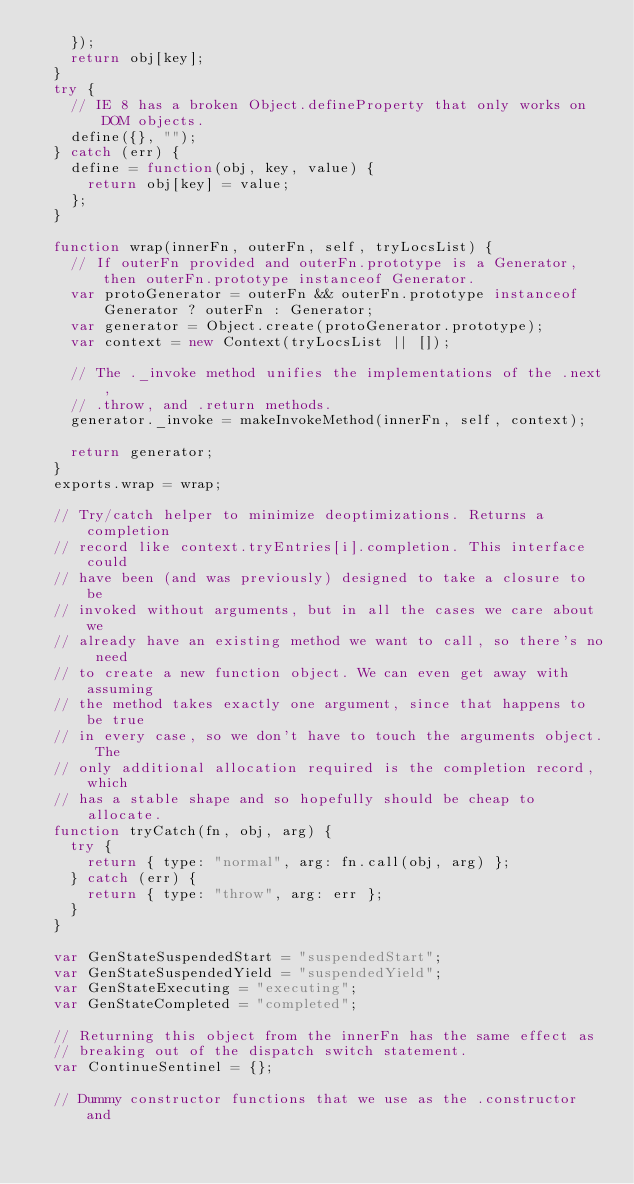<code> <loc_0><loc_0><loc_500><loc_500><_JavaScript_>    });
    return obj[key];
  }
  try {
    // IE 8 has a broken Object.defineProperty that only works on DOM objects.
    define({}, "");
  } catch (err) {
    define = function(obj, key, value) {
      return obj[key] = value;
    };
  }

  function wrap(innerFn, outerFn, self, tryLocsList) {
    // If outerFn provided and outerFn.prototype is a Generator, then outerFn.prototype instanceof Generator.
    var protoGenerator = outerFn && outerFn.prototype instanceof Generator ? outerFn : Generator;
    var generator = Object.create(protoGenerator.prototype);
    var context = new Context(tryLocsList || []);

    // The ._invoke method unifies the implementations of the .next,
    // .throw, and .return methods.
    generator._invoke = makeInvokeMethod(innerFn, self, context);

    return generator;
  }
  exports.wrap = wrap;

  // Try/catch helper to minimize deoptimizations. Returns a completion
  // record like context.tryEntries[i].completion. This interface could
  // have been (and was previously) designed to take a closure to be
  // invoked without arguments, but in all the cases we care about we
  // already have an existing method we want to call, so there's no need
  // to create a new function object. We can even get away with assuming
  // the method takes exactly one argument, since that happens to be true
  // in every case, so we don't have to touch the arguments object. The
  // only additional allocation required is the completion record, which
  // has a stable shape and so hopefully should be cheap to allocate.
  function tryCatch(fn, obj, arg) {
    try {
      return { type: "normal", arg: fn.call(obj, arg) };
    } catch (err) {
      return { type: "throw", arg: err };
    }
  }

  var GenStateSuspendedStart = "suspendedStart";
  var GenStateSuspendedYield = "suspendedYield";
  var GenStateExecuting = "executing";
  var GenStateCompleted = "completed";

  // Returning this object from the innerFn has the same effect as
  // breaking out of the dispatch switch statement.
  var ContinueSentinel = {};

  // Dummy constructor functions that we use as the .constructor and</code> 